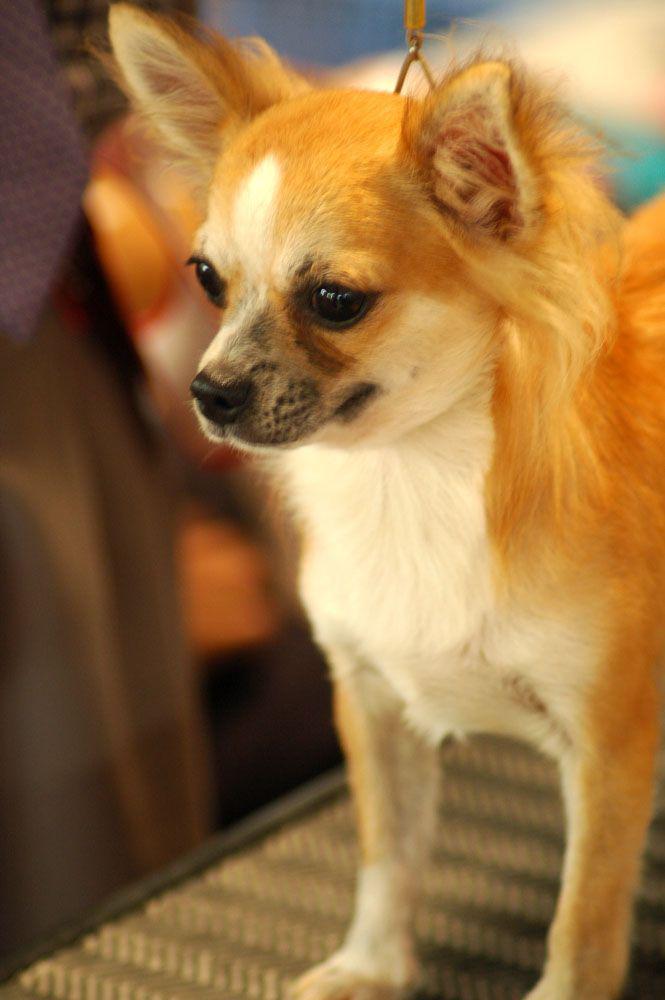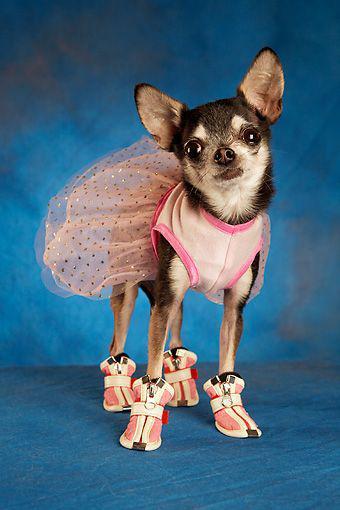The first image is the image on the left, the second image is the image on the right. Evaluate the accuracy of this statement regarding the images: "The dog dressed in costume in the right hand image is photographed against a blue background.". Is it true? Answer yes or no. Yes. The first image is the image on the left, the second image is the image on the right. For the images displayed, is the sentence "The right image contains a dog wearing a small hat." factually correct? Answer yes or no. No. 